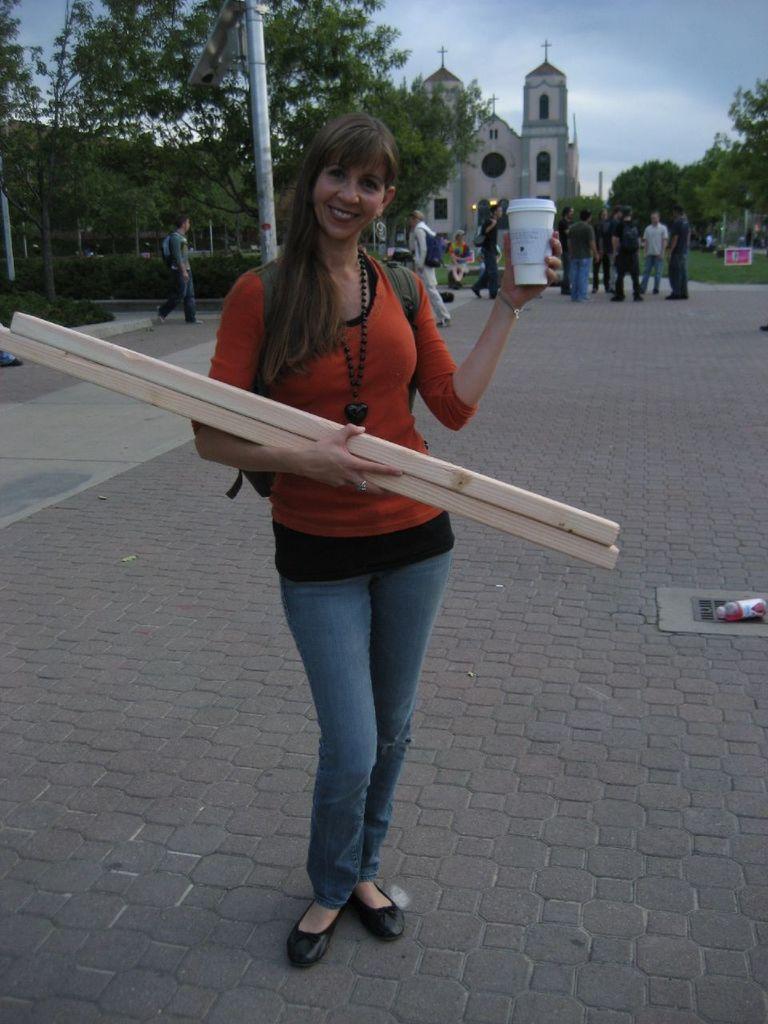Can you describe this image briefly? This is an outside view. Here I can see a woman holding wooden sticks and a bottle in the hands, standing on the road, smiling and giving pose for the picture. In the background there are some more people standing and few people are walking and also there are some trees, a pole and a building. At the top of the image I can see the sky. 